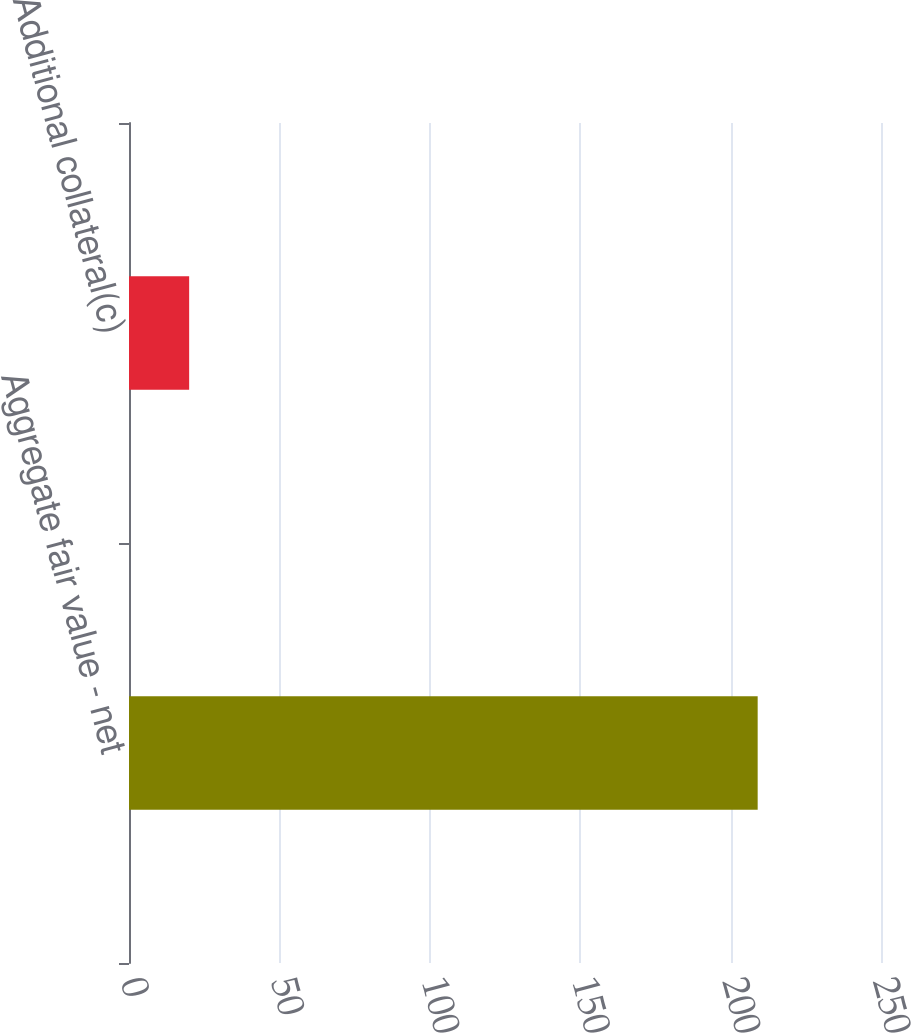<chart> <loc_0><loc_0><loc_500><loc_500><bar_chart><fcel>Aggregate fair value - net<fcel>Additional collateral(c)<nl><fcel>209<fcel>20<nl></chart> 